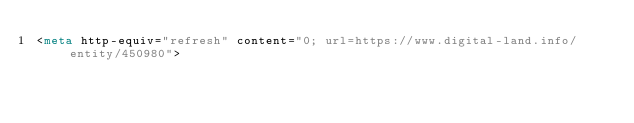Convert code to text. <code><loc_0><loc_0><loc_500><loc_500><_HTML_><meta http-equiv="refresh" content="0; url=https://www.digital-land.info/entity/450980"></code> 